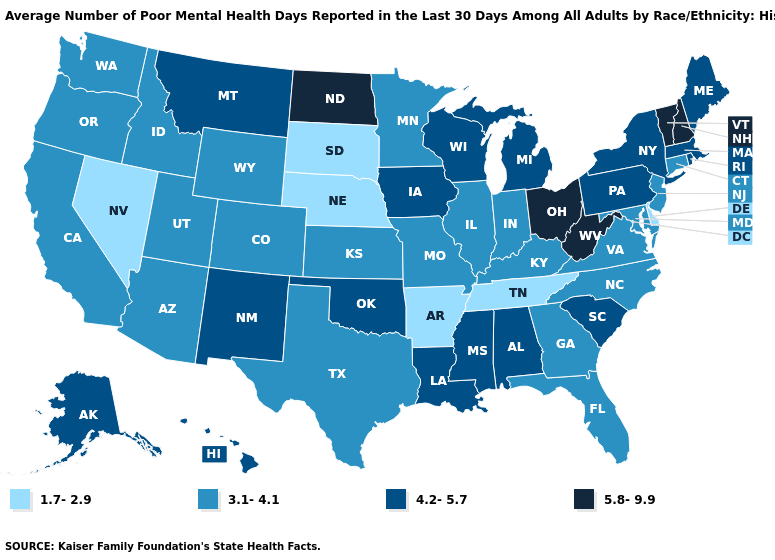Which states have the lowest value in the USA?
Give a very brief answer. Arkansas, Delaware, Nebraska, Nevada, South Dakota, Tennessee. Name the states that have a value in the range 4.2-5.7?
Keep it brief. Alabama, Alaska, Hawaii, Iowa, Louisiana, Maine, Massachusetts, Michigan, Mississippi, Montana, New Mexico, New York, Oklahoma, Pennsylvania, Rhode Island, South Carolina, Wisconsin. Name the states that have a value in the range 5.8-9.9?
Give a very brief answer. New Hampshire, North Dakota, Ohio, Vermont, West Virginia. Among the states that border Idaho , does Nevada have the lowest value?
Short answer required. Yes. Does North Dakota have the highest value in the USA?
Write a very short answer. Yes. Among the states that border Maine , which have the lowest value?
Keep it brief. New Hampshire. Name the states that have a value in the range 3.1-4.1?
Answer briefly. Arizona, California, Colorado, Connecticut, Florida, Georgia, Idaho, Illinois, Indiana, Kansas, Kentucky, Maryland, Minnesota, Missouri, New Jersey, North Carolina, Oregon, Texas, Utah, Virginia, Washington, Wyoming. Among the states that border Arkansas , which have the highest value?
Keep it brief. Louisiana, Mississippi, Oklahoma. What is the lowest value in states that border Washington?
Concise answer only. 3.1-4.1. Which states have the lowest value in the West?
Quick response, please. Nevada. Does Wisconsin have a higher value than Maine?
Be succinct. No. What is the highest value in the Northeast ?
Answer briefly. 5.8-9.9. Name the states that have a value in the range 4.2-5.7?
Write a very short answer. Alabama, Alaska, Hawaii, Iowa, Louisiana, Maine, Massachusetts, Michigan, Mississippi, Montana, New Mexico, New York, Oklahoma, Pennsylvania, Rhode Island, South Carolina, Wisconsin. Does Connecticut have a lower value than Nevada?
Give a very brief answer. No. Among the states that border Colorado , which have the highest value?
Concise answer only. New Mexico, Oklahoma. 